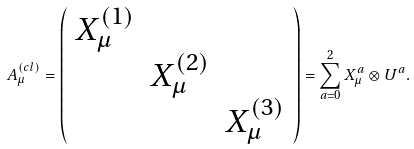<formula> <loc_0><loc_0><loc_500><loc_500>A _ { \mu } ^ { ( c l ) } = \left ( \begin{array} { c c c } X _ { \mu } ^ { ( 1 ) } & & \\ & X _ { \mu } ^ { ( 2 ) } & \\ & & X _ { \mu } ^ { ( 3 ) } \end{array} \right ) = \sum _ { a = 0 } ^ { 2 } X _ { \mu } ^ { a } \otimes U ^ { a } .</formula> 